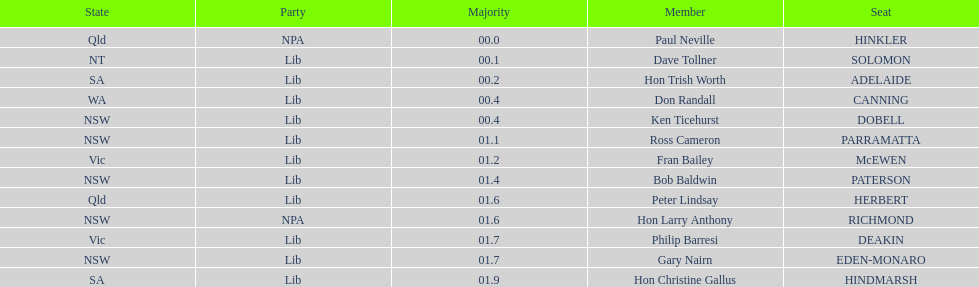How many states were represented in the seats? 6. 